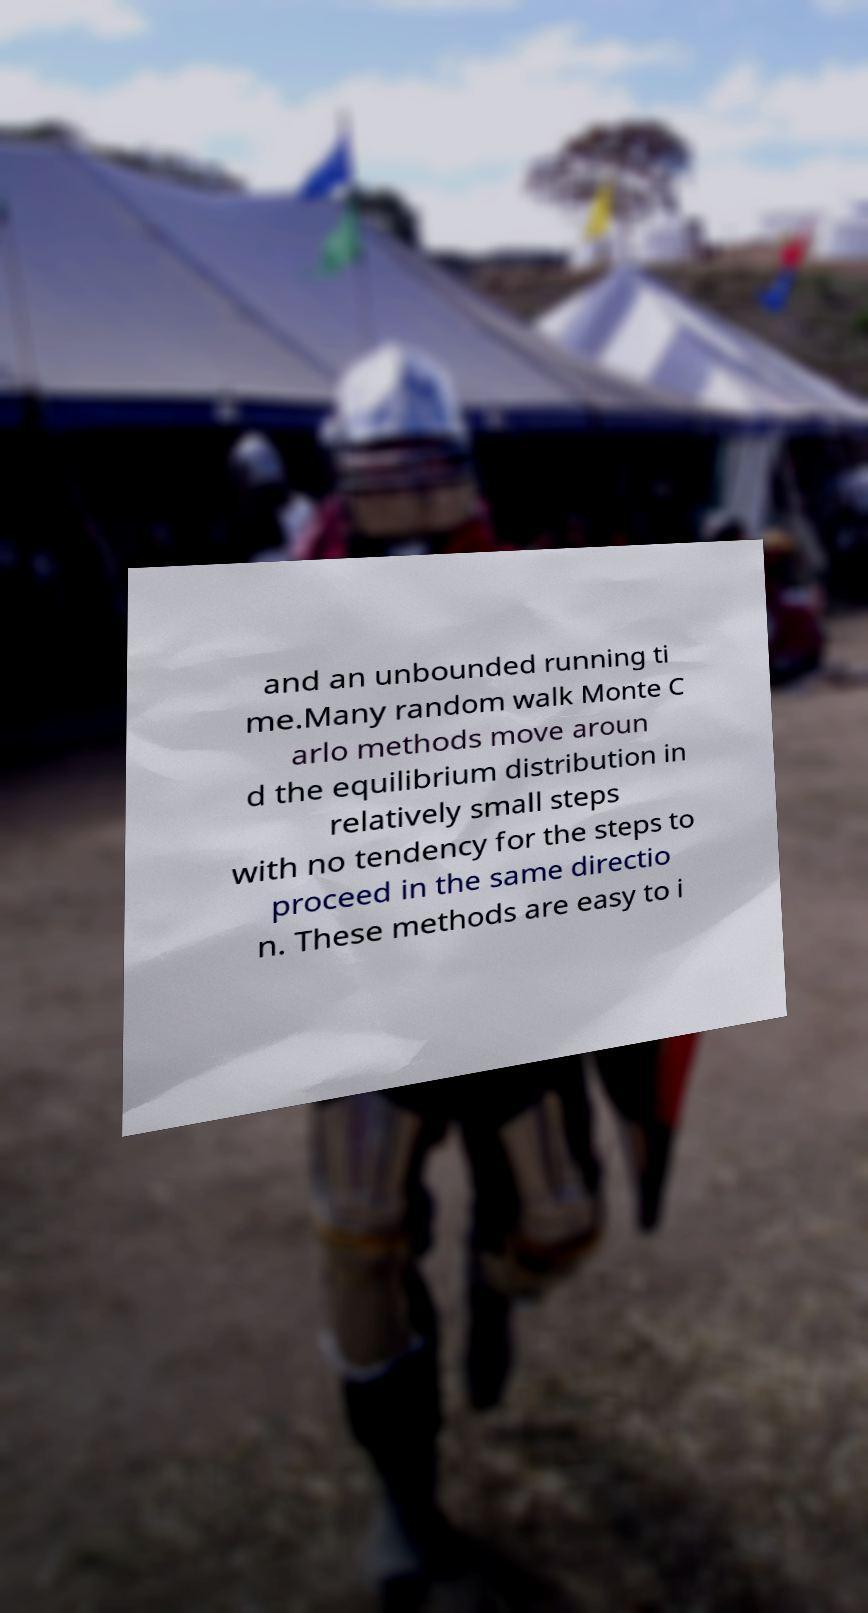Please read and relay the text visible in this image. What does it say? and an unbounded running ti me.Many random walk Monte C arlo methods move aroun d the equilibrium distribution in relatively small steps with no tendency for the steps to proceed in the same directio n. These methods are easy to i 